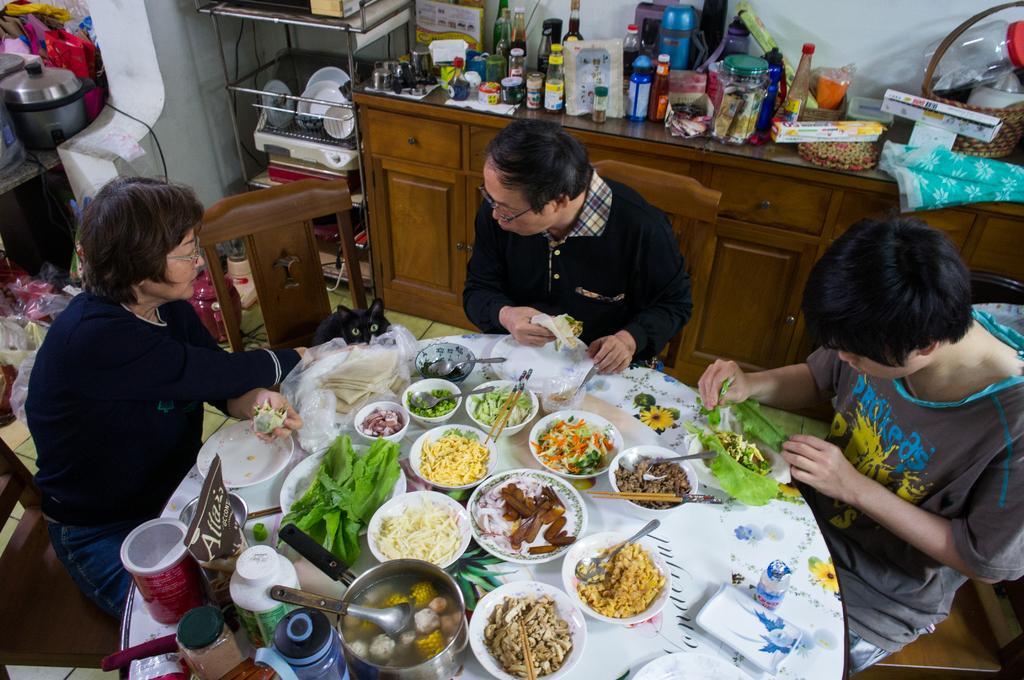Please provide a concise description of this image. In this image there is floor at the bottom. There are people, chairs, and a table with food items on it in the foreground. There is a cupboard with bottles and other objects on it and there is a metal stand with objects on it and a wall in the background. 